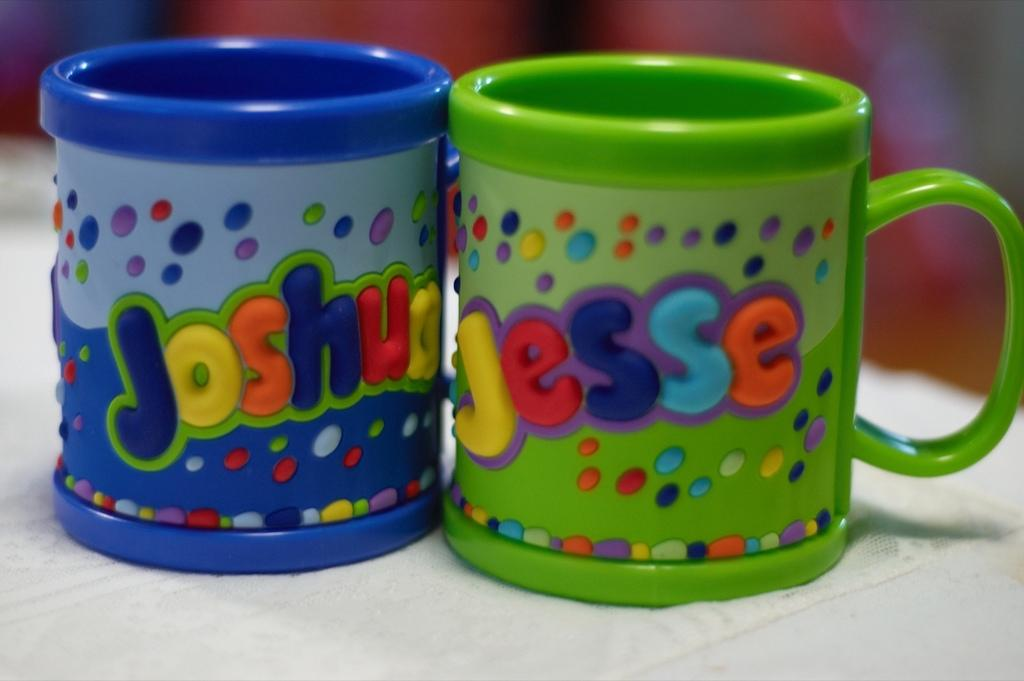<image>
Offer a succinct explanation of the picture presented. two cups with one that says Jesse on it 